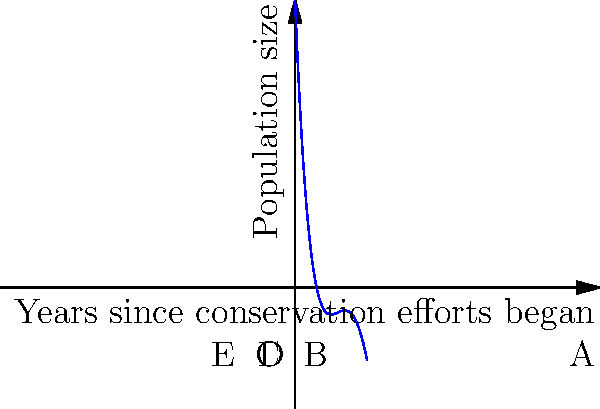The graph represents the population size of an endangered species over time since conservation efforts began. The function is modeled by the quartic polynomial $f(x) = 0.01x^4 - 0.4x^3 + 5x^2 - 25x + 40$, where $x$ represents years and $f(x)$ represents population size. At which point does the population reach its minimum, and what does this suggest about the effectiveness of the conservation efforts? To find the minimum point, we need to follow these steps:

1) First, we need to find the derivative of the function:
   $f'(x) = 0.04x^3 - 1.2x^2 + 10x - 25$

2) Set the derivative equal to zero to find critical points:
   $0.04x^3 - 1.2x^2 + 10x - 25 = 0$

3) This is a cubic equation. From the graph, we can see that the minimum occurs around $x = 2.5$, which corresponds to point B.

4) To verify, we can check the second derivative:
   $f''(x) = 0.12x^2 - 2.4x + 10$
   $f''(2.5) = 0.12(2.5)^2 - 2.4(2.5) + 10 = 4.25 > 0$

   This confirms that $x = 2.5$ is indeed a local minimum.

5) Interpreting the result:
   The population reaches its minimum after about 2.5 years of conservation efforts. This suggests that the conservation efforts take some time to show positive effects. Initially, the population continues to decline, but after 2.5 years, it starts to recover.

6) The effectiveness of the conservation efforts is demonstrated by the population's recovery after the 2.5-year mark, showing a positive long-term impact despite initial challenges.
Answer: Point B (2.5 years); initial decline followed by recovery indicates eventual effectiveness of conservation efforts. 